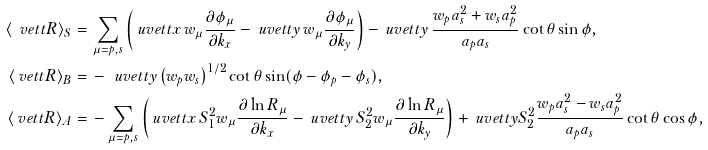Convert formula to latex. <formula><loc_0><loc_0><loc_500><loc_500>\langle \ v e t t { R } \rangle _ { S } = & \, \sum _ { \mu = p , s } \left ( \ u v e t t { x } \, w _ { \mu } \frac { \partial \phi _ { \mu } } { \partial k _ { x } } - \ u v e t t { y } \, w _ { \mu } \frac { \partial \phi _ { \mu } } { \partial k _ { y } } \right ) - \ u v e t t { y } \, \frac { w _ { p } a _ { s } ^ { 2 } + w _ { s } a _ { p } ^ { 2 } } { a _ { p } a _ { s } } \cot \theta \sin \phi , \\ \langle \ v e t t { R } \rangle _ { B } = & \, - \, \ u v e t t { y } \left ( w _ { p } w _ { s } \right ) ^ { 1 / 2 } \cot \theta \sin ( \phi - \phi _ { p } - \phi _ { s } ) , \\ \langle \ v e t t { R } \rangle _ { A } = & \, - \sum _ { \mu = p , s } \left ( \ u v e t t { x } \, S _ { 1 } ^ { 2 } w _ { \mu } \frac { \partial \ln R _ { \mu } } { \partial k _ { x } } - \ u v e t t { y } \, S _ { 2 } ^ { 2 } w _ { \mu } \frac { \partial \ln R _ { \mu } } { \partial k _ { y } } \right ) + \ u v e t t { y } S _ { 2 } ^ { 2 } \frac { w _ { p } a _ { s } ^ { 2 } - w _ { s } a _ { p } ^ { 2 } } { a _ { p } a _ { s } } \cot \theta \cos \phi ,</formula> 